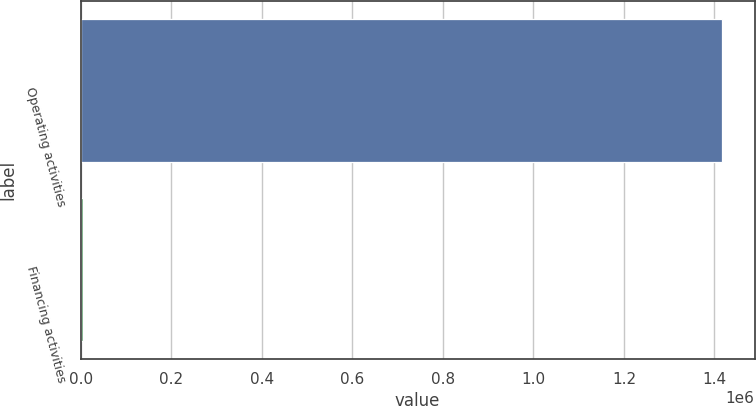Convert chart. <chart><loc_0><loc_0><loc_500><loc_500><bar_chart><fcel>Operating activities<fcel>Financing activities<nl><fcel>1.41762e+06<fcel>5849<nl></chart> 